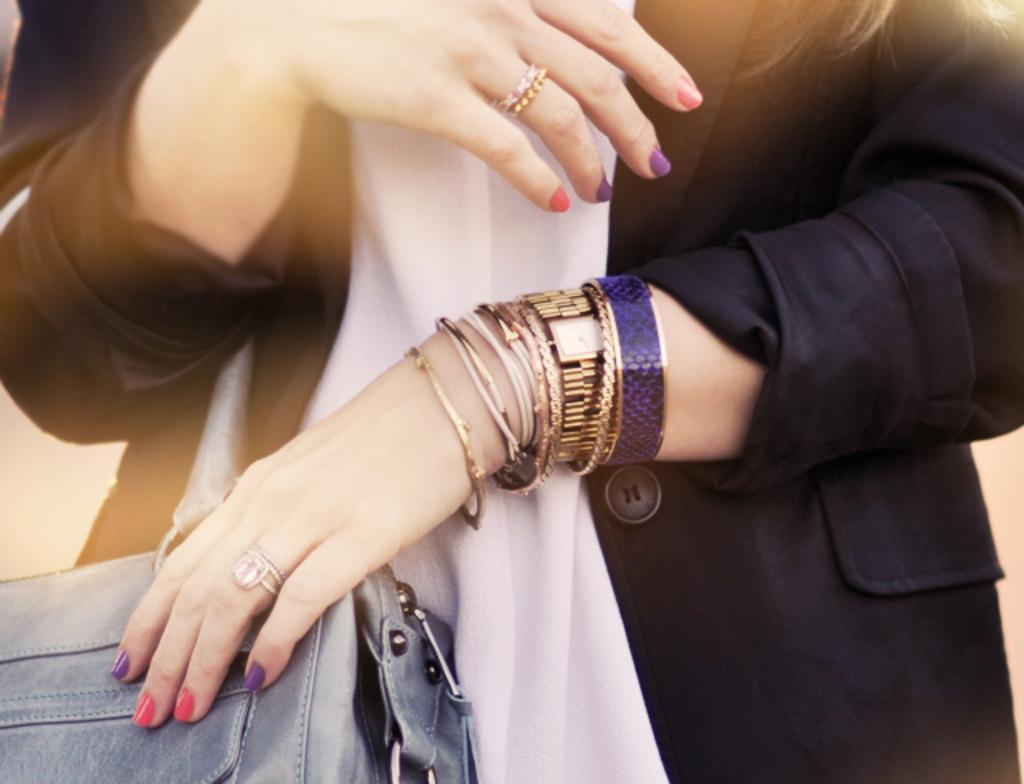Please provide a concise description of this image. In this image I can see a person and wearing a bag. She is wearing black and white color dress. I can see bands,rings and watch. 